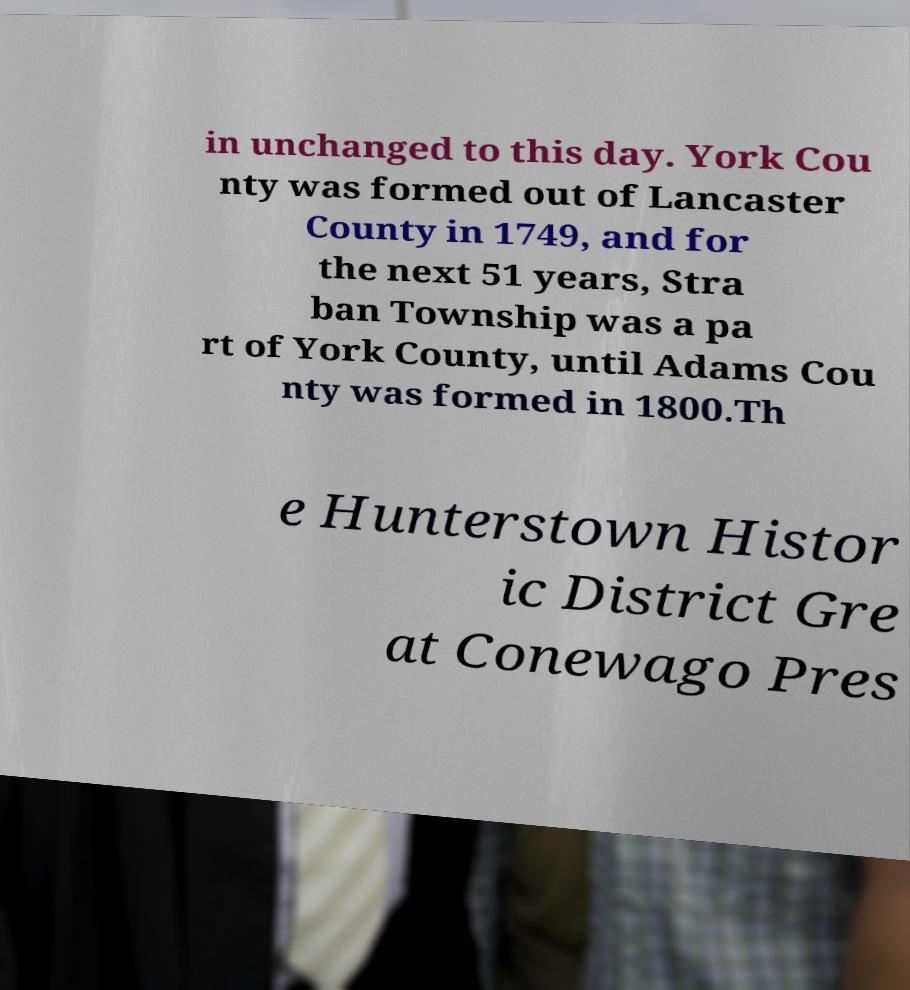I need the written content from this picture converted into text. Can you do that? in unchanged to this day. York Cou nty was formed out of Lancaster County in 1749, and for the next 51 years, Stra ban Township was a pa rt of York County, until Adams Cou nty was formed in 1800.Th e Hunterstown Histor ic District Gre at Conewago Pres 